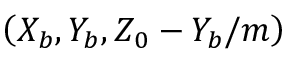<formula> <loc_0><loc_0><loc_500><loc_500>\left ( X _ { b } , Y _ { b } , Z _ { 0 } - Y _ { b } / m \right )</formula> 